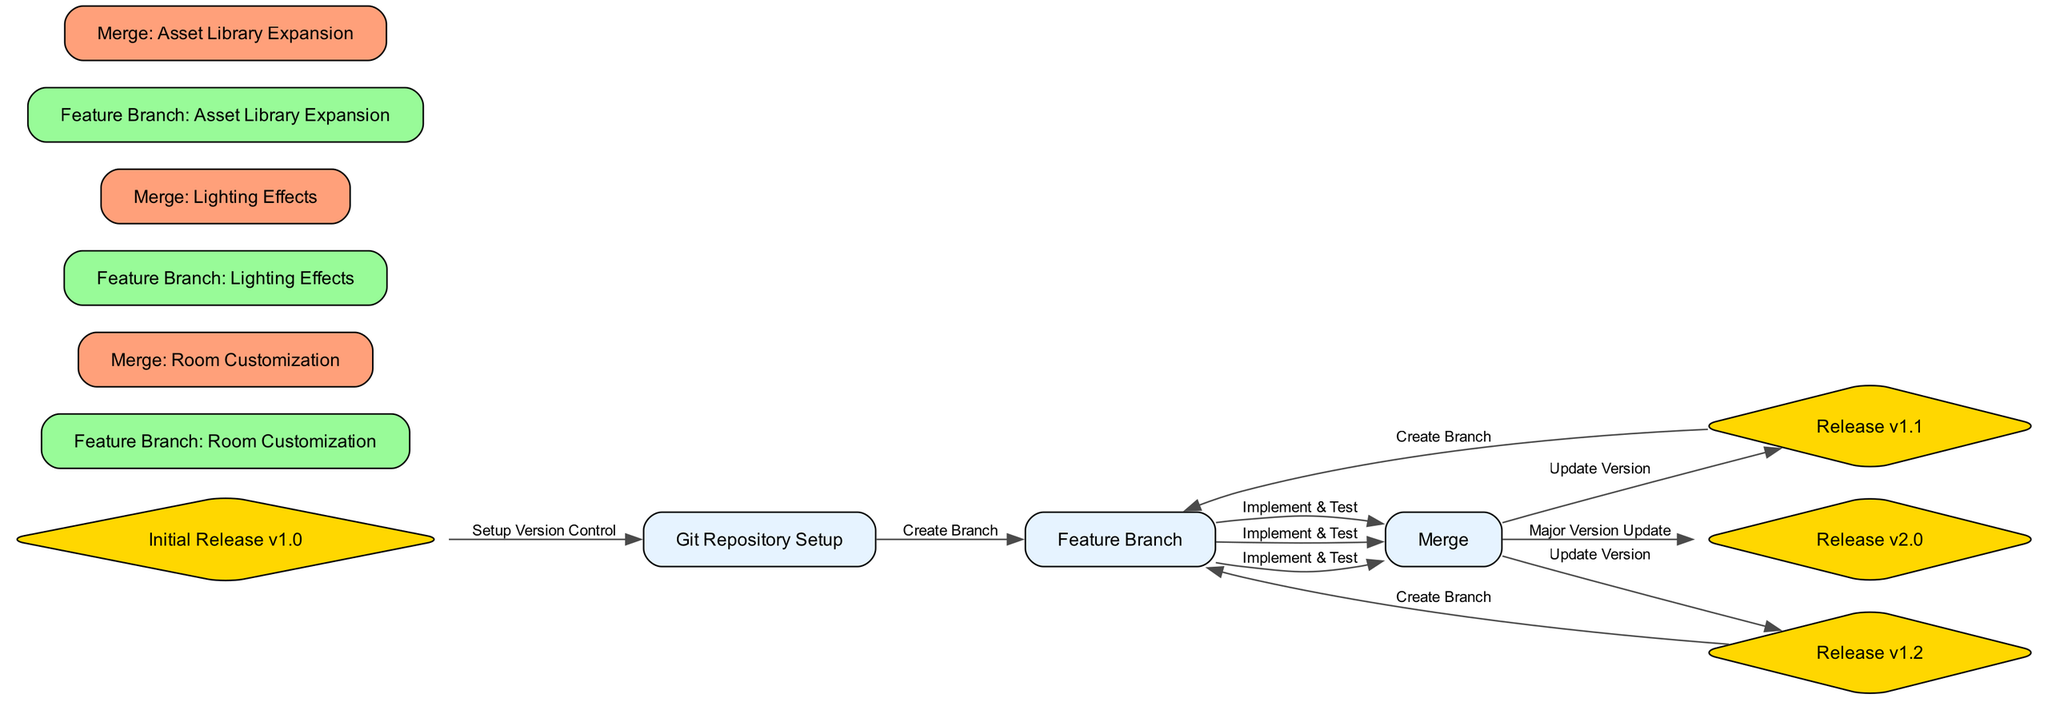What is the total number of nodes in the diagram? The diagram contains a list of nodes: "Initial Release v1.0", "Git Repository Setup", "Feature Branch: Room Customization", "Merge: Room Customization", "Release v1.1", "Feature Branch: Lighting Effects", "Merge: Lighting Effects", "Release v1.2", "Feature Branch: Asset Library Expansion", "Merge: Asset Library Expansion", and "Release v2.0". Counting these, there are 11 nodes in total.
Answer: 11 What label signifies the transition from the feature branch to the merge for lighting effects? To find the label, we look at the edge between "Feature Branch: Lighting Effects" and "Merge: Lighting Effects", which is labeled "Implement & Test".
Answer: Implement & Test Which feature branch was created after the release of version 1.1? By examining the edges in the diagram, after "Release v1.1", the next node is "Feature Branch: Lighting Effects". This indicates that this feature branch was created immediately following the release.
Answer: Feature Branch: Lighting Effects How many merges are shown in the graph? We can identify merges in the diagram by looking for nodes that are labeled as "Merge". The nodes are "Merge: Room Customization", "Merge: Lighting Effects", and "Merge: Asset Library Expansion". Counting these, there are three merges in total.
Answer: 3 What is the final release version in the timeline? Looking at the diagram, the last node in the sequence is "Release v2.0", which indicates the final release version of the software according to the timeline presented.
Answer: Release v2.0 What is the relationship between "Merge: Asset Library Expansion" and "Release v2.0"? The edge connecting "Merge: Asset Library Expansion" to "Release v2.0" is labeled "Major Version Update". This demonstrates that the merge directly leads to the final release version.
Answer: Major Version Update Which action comes before the release of version 1.2? By tracing the nodes leading up to "Release v1.2", we observe that "Merge: Lighting Effects" directly precedes it. This indicates the last step completed before version 1.2 is released is the merge action.
Answer: Merge: Lighting Effects Which version control setup action is depicted at the beginning of the graph? The diagram starts with "Git Repository Setup", which indicates the initial action taken for setting up version control for the software development process.
Answer: Git Repository Setup 